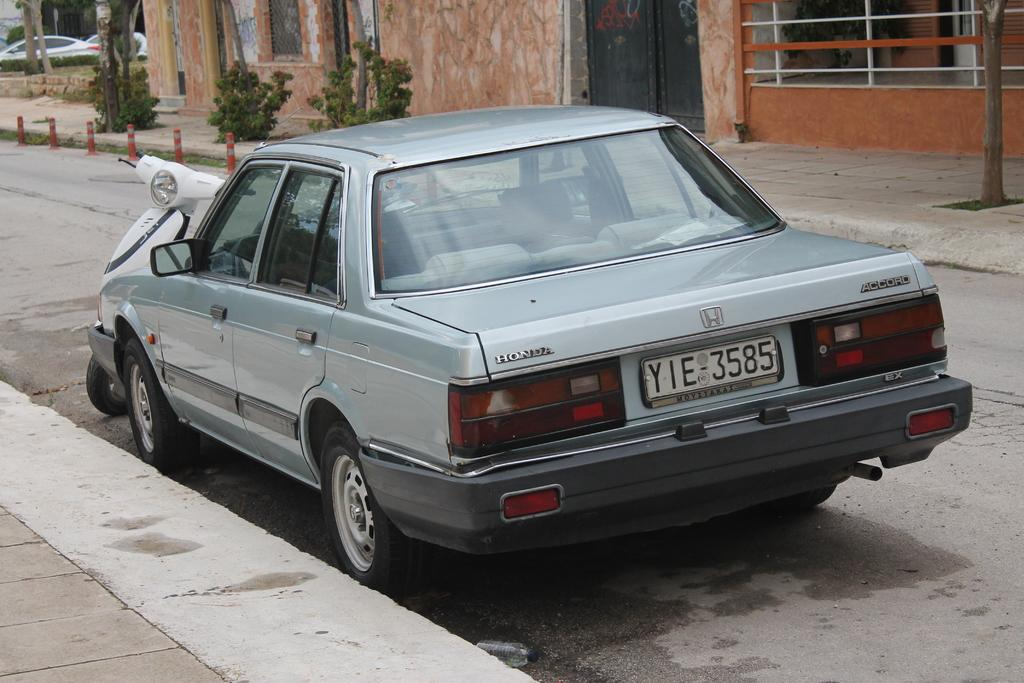What are the main subjects in the center of the image? There is a scooter and a car in the center of the image. Where are the scooter and car located? Both the scooter and car are on the road. What can be seen in the background of the image? There are plants, trees, at least one building, and cars visible in the background of the image. What type of breakfast is being served on the scooter in the image? There is no breakfast present in the image; it features a scooter and a car on the road, with a background that includes plants, trees, a building, and cars. 